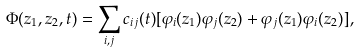Convert formula to latex. <formula><loc_0><loc_0><loc_500><loc_500>\Phi ( z _ { 1 } , z _ { 2 } , t ) = \sum _ { i , j } c _ { i j } ( t ) [ \varphi _ { i } ( z _ { 1 } ) \varphi _ { j } ( z _ { 2 } ) + \varphi _ { j } ( z _ { 1 } ) \varphi _ { i } ( z _ { 2 } ) ] ,</formula> 